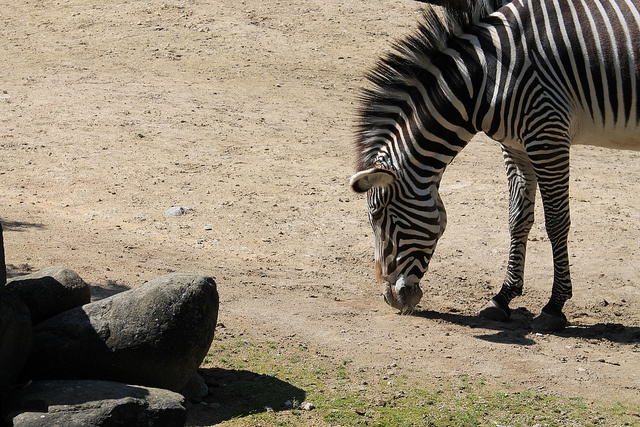Describe the objects in this image and their specific colors. I can see a zebra in tan, black, gray, and darkgray tones in this image. 